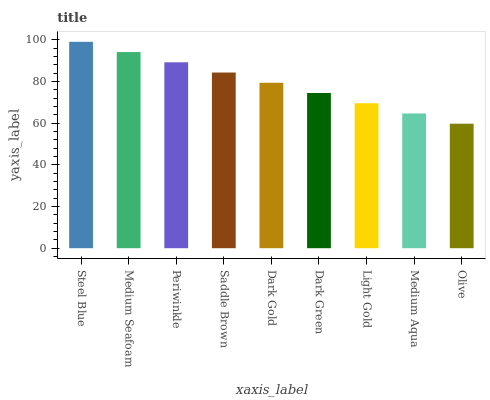Is Olive the minimum?
Answer yes or no. Yes. Is Steel Blue the maximum?
Answer yes or no. Yes. Is Medium Seafoam the minimum?
Answer yes or no. No. Is Medium Seafoam the maximum?
Answer yes or no. No. Is Steel Blue greater than Medium Seafoam?
Answer yes or no. Yes. Is Medium Seafoam less than Steel Blue?
Answer yes or no. Yes. Is Medium Seafoam greater than Steel Blue?
Answer yes or no. No. Is Steel Blue less than Medium Seafoam?
Answer yes or no. No. Is Dark Gold the high median?
Answer yes or no. Yes. Is Dark Gold the low median?
Answer yes or no. Yes. Is Steel Blue the high median?
Answer yes or no. No. Is Saddle Brown the low median?
Answer yes or no. No. 